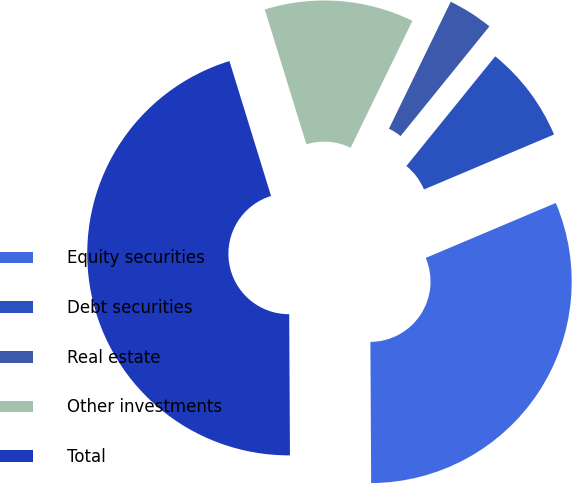Convert chart to OTSL. <chart><loc_0><loc_0><loc_500><loc_500><pie_chart><fcel>Equity securities<fcel>Debt securities<fcel>Real estate<fcel>Other investments<fcel>Total<nl><fcel>31.28%<fcel>7.8%<fcel>3.63%<fcel>11.97%<fcel>45.33%<nl></chart> 